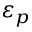Convert formula to latex. <formula><loc_0><loc_0><loc_500><loc_500>\varepsilon _ { p }</formula> 